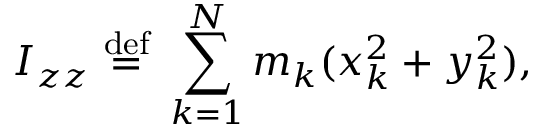<formula> <loc_0><loc_0><loc_500><loc_500>I _ { z z } \ { \stackrel { d e f } { = } } \ \sum _ { k = 1 } ^ { N } m _ { k } ( x _ { k } ^ { 2 } + y _ { k } ^ { 2 } ) , \,</formula> 